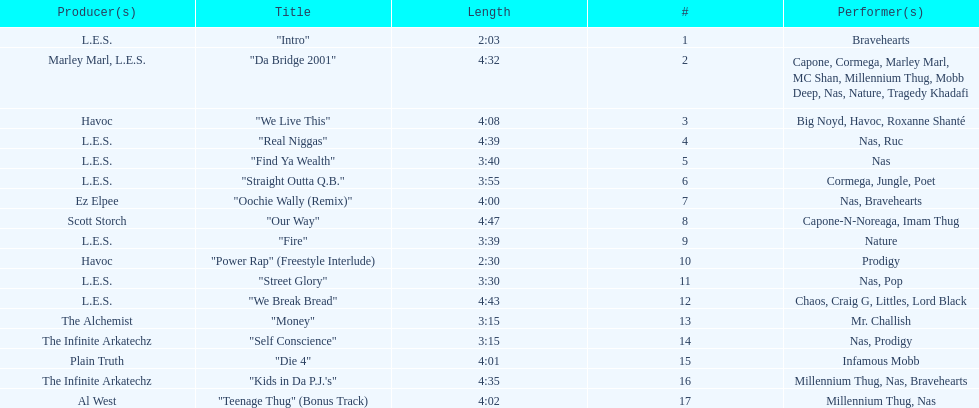What is the name of the last song on the album? "Teenage Thug" (Bonus Track). 